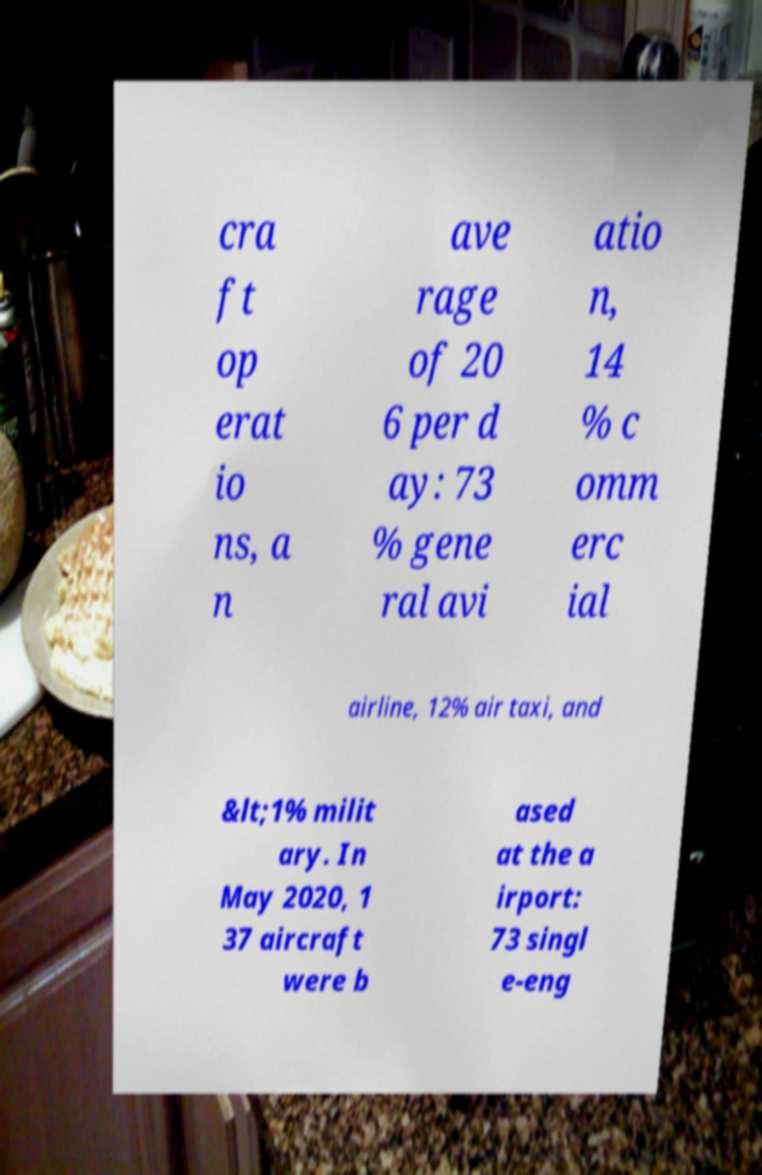Could you assist in decoding the text presented in this image and type it out clearly? cra ft op erat io ns, a n ave rage of 20 6 per d ay: 73 % gene ral avi atio n, 14 % c omm erc ial airline, 12% air taxi, and &lt;1% milit ary. In May 2020, 1 37 aircraft were b ased at the a irport: 73 singl e-eng 